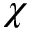Convert formula to latex. <formula><loc_0><loc_0><loc_500><loc_500>\chi</formula> 